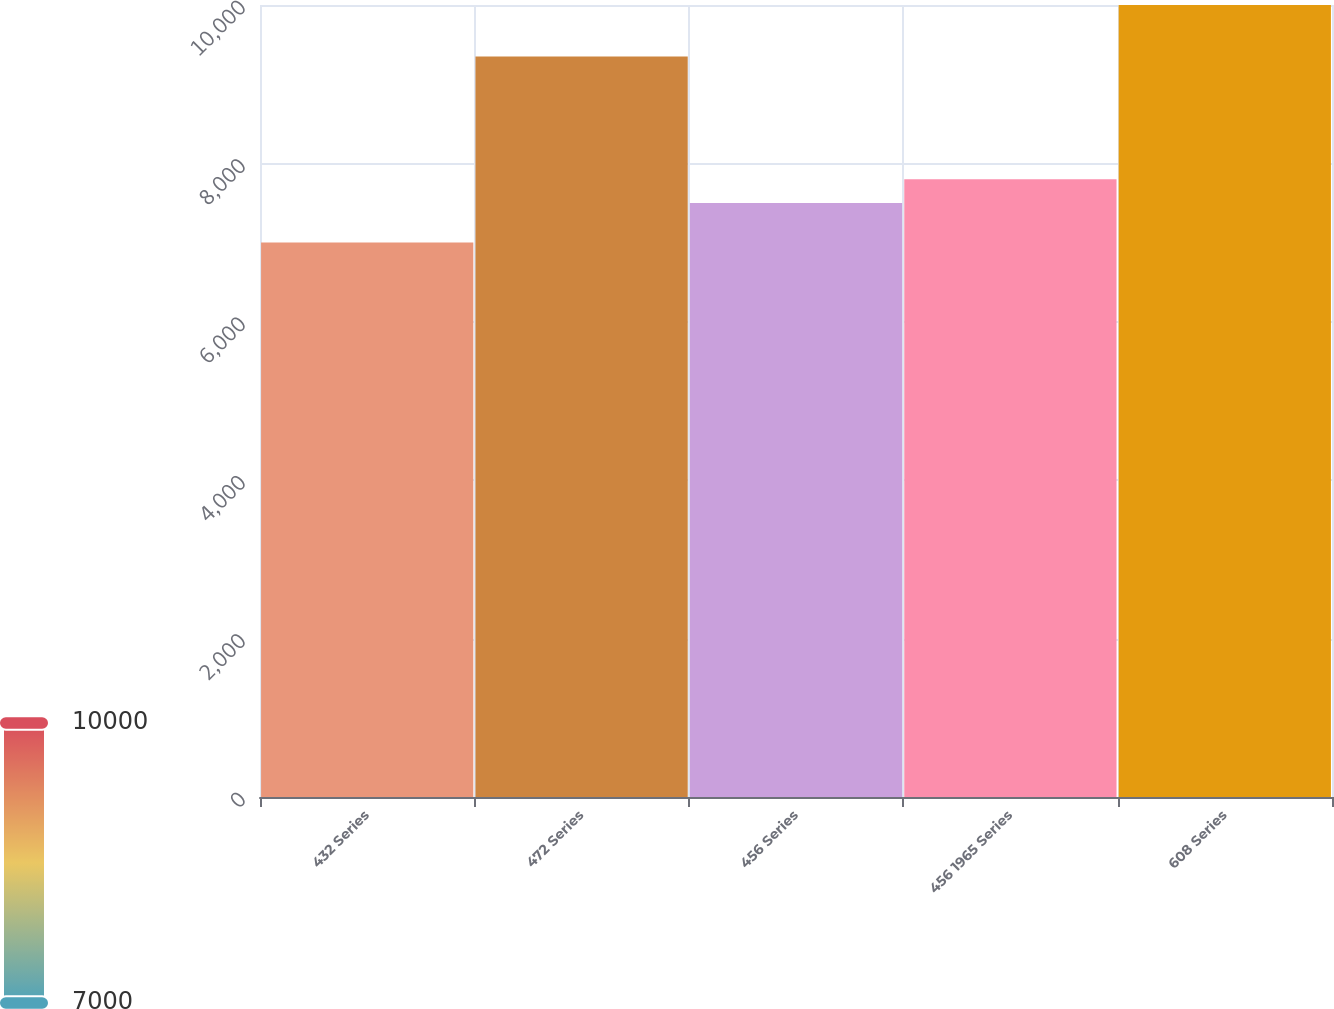Convert chart to OTSL. <chart><loc_0><loc_0><loc_500><loc_500><bar_chart><fcel>432 Series<fcel>472 Series<fcel>456 Series<fcel>456 1965 Series<fcel>608 Series<nl><fcel>7000<fcel>9350<fcel>7500<fcel>7800<fcel>10000<nl></chart> 